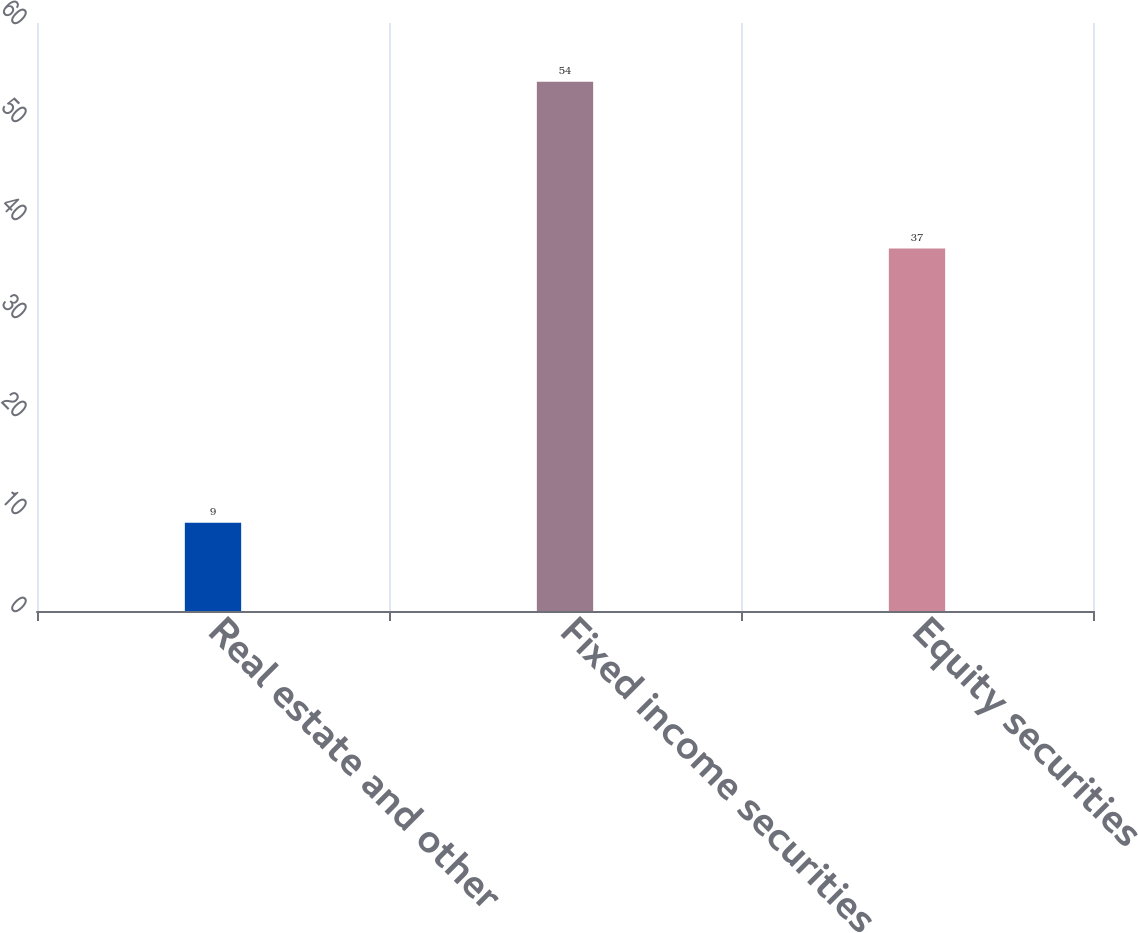Convert chart to OTSL. <chart><loc_0><loc_0><loc_500><loc_500><bar_chart><fcel>Real estate and other<fcel>Fixed income securities<fcel>Equity securities<nl><fcel>9<fcel>54<fcel>37<nl></chart> 